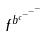Convert formula to latex. <formula><loc_0><loc_0><loc_500><loc_500>f ^ { b ^ { c ^ { - ^ { - ^ { - } } } } }</formula> 